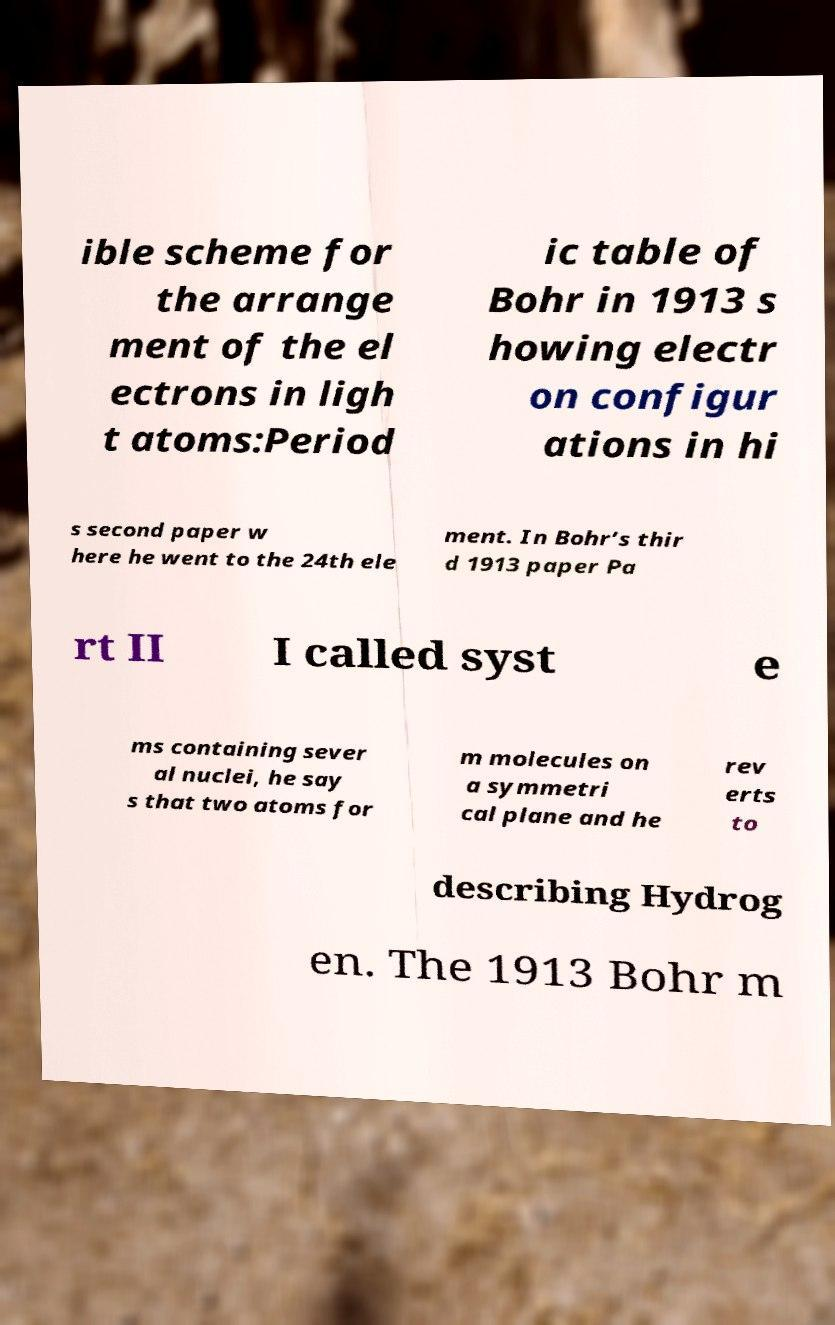What messages or text are displayed in this image? I need them in a readable, typed format. ible scheme for the arrange ment of the el ectrons in ligh t atoms:Period ic table of Bohr in 1913 s howing electr on configur ations in hi s second paper w here he went to the 24th ele ment. In Bohr’s thir d 1913 paper Pa rt II I called syst e ms containing sever al nuclei, he say s that two atoms for m molecules on a symmetri cal plane and he rev erts to describing Hydrog en. The 1913 Bohr m 